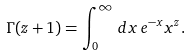<formula> <loc_0><loc_0><loc_500><loc_500>\Gamma ( z + 1 ) = \int ^ { \infty } _ { 0 } \, d x \, e ^ { - x } x ^ { z } .</formula> 